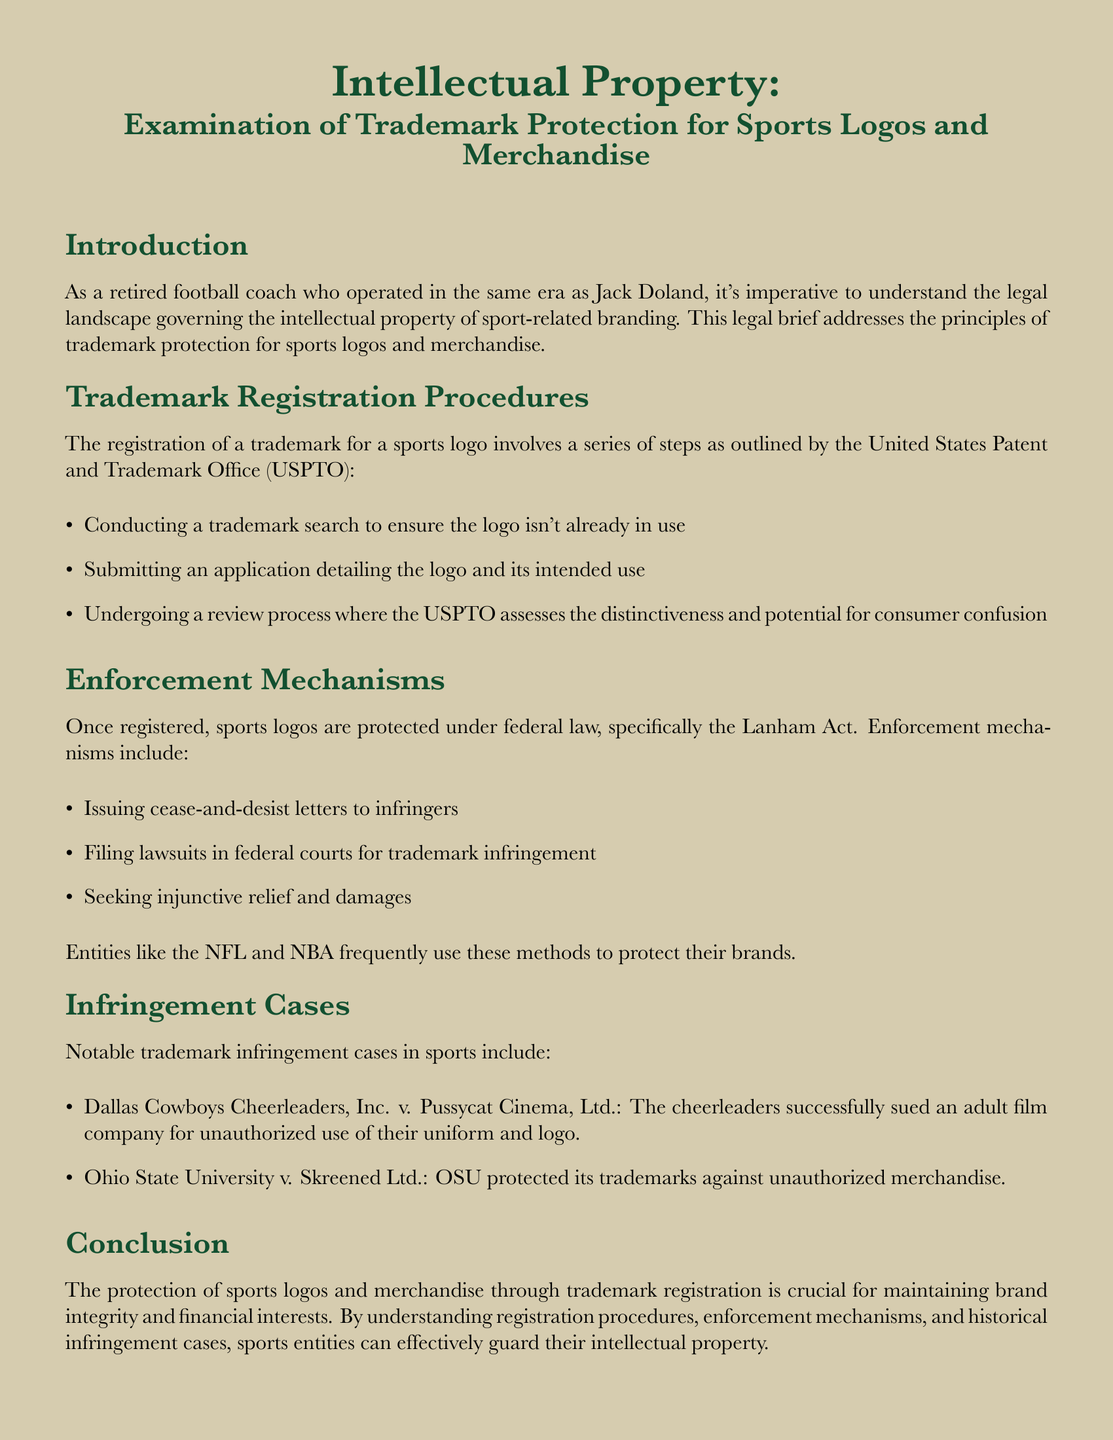what federal law protects registered sports logos? The document states that sports logos are protected under federal law, specifically the Lanham Act.
Answer: Lanham Act what is the first step in registering a trademark for a sports logo? The first step outlined is conducting a trademark search to ensure the logo isn't already in use.
Answer: Conducting a trademark search what was the outcome of Dallas Cowboys Cheerleaders, Inc. v. Pussycat Cinema, Ltd.? The document indicates that the cheerleaders successfully sued for unauthorized use of their uniform and logo.
Answer: Successfully sued which institution oversees trademark registration in the United States? The document mentions the United States Patent and Trademark Office (USPTO) as the overseeing institution.
Answer: United States Patent and Trademark Office (USPTO) how many notable infringement cases are listed in the document? The document lists two notable trademark infringement cases in sports.
Answer: Two what is one method of enforcement mentioned for protecting trademarks? The document outlines issuing cease-and-desist letters as one method of enforcement for protecting trademarks.
Answer: Issuing cease-and-desist letters what is the purpose of trademark registration for sports logos and merchandise? The document states that the purpose is to maintain brand integrity and financial interests.
Answer: Maintain brand integrity and financial interests which sports entities are mentioned as often using enforcement methods? The document refers to the NFL and NBA as entities that frequently use enforcement methods to protect their brands.
Answer: NFL and NBA 